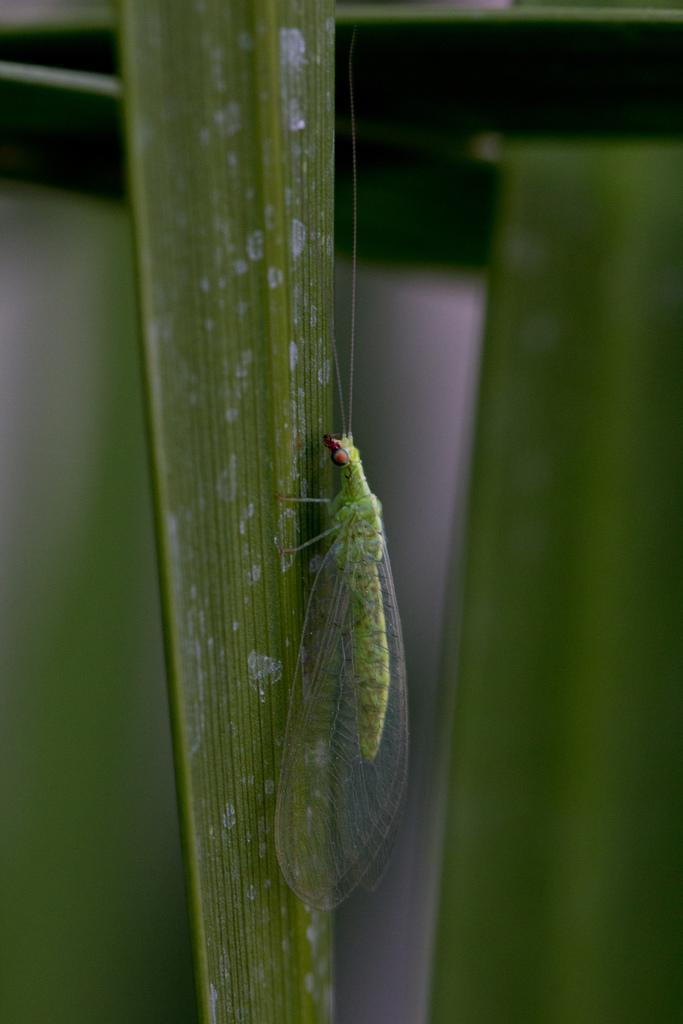What is present on the leaf in the image? There is an insect on a leaf in the image. Can you describe the background of the image? The background of the image is blurry. What type of ear is visible on the insect in the image? There is no ear visible on the insect in the image, as insects do not have ears like mammals. Can you see a giraffe in the image? No, there is no giraffe present in the image. 